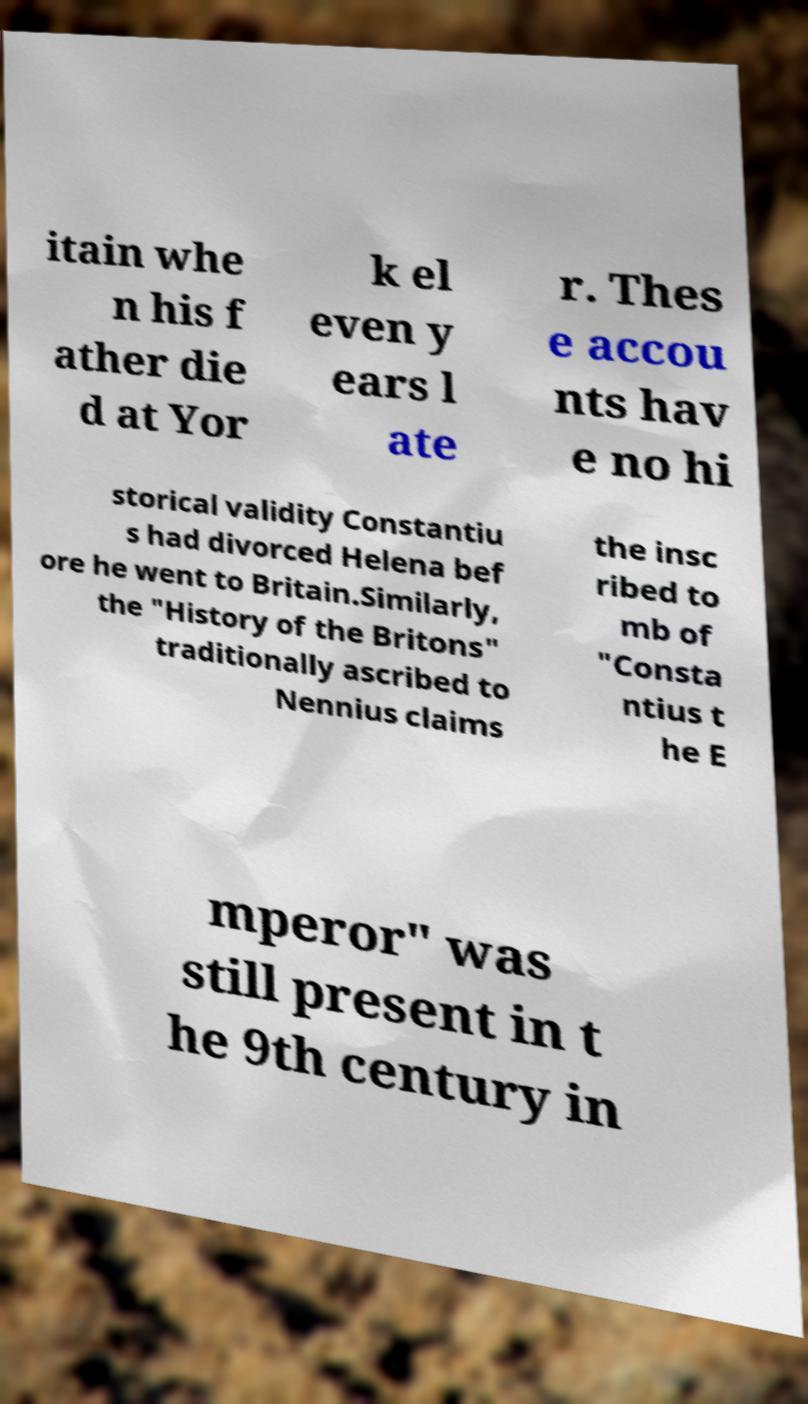I need the written content from this picture converted into text. Can you do that? itain whe n his f ather die d at Yor k el even y ears l ate r. Thes e accou nts hav e no hi storical validity Constantiu s had divorced Helena bef ore he went to Britain.Similarly, the "History of the Britons" traditionally ascribed to Nennius claims the insc ribed to mb of "Consta ntius t he E mperor" was still present in t he 9th century in 